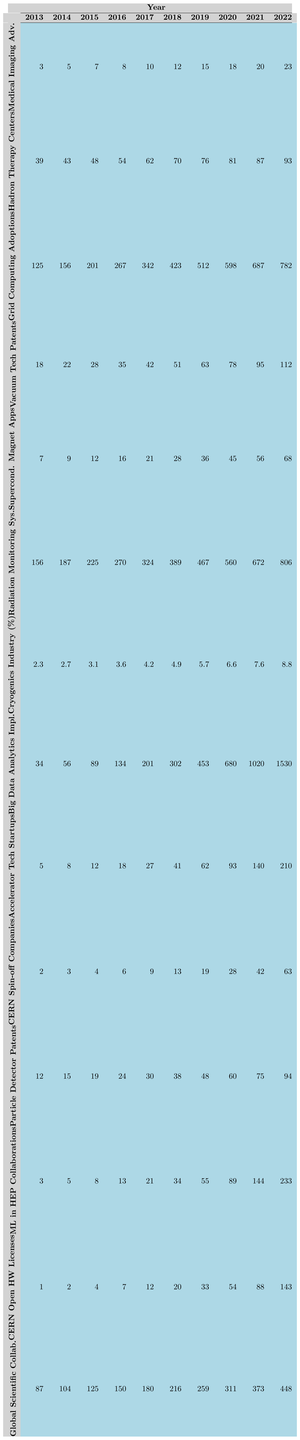What is the value for Radiation Monitoring Systems in 2021? In the table, under the column for Radiation Monitoring Systems, the value corresponding to the year 2021 is 672.
Answer: 672 How many Hadron Therapy Centers were there in 2019? Referring to the Hadron Therapy Centers row, for the year 2019 the value is 76.
Answer: 76 What was the increase in Vacuum Technology Patents from 2013 to 2022? The value in 2013 was 18 and in 2022 it was 112. The increase is 112 - 18 = 94.
Answer: 94 What is the average number of CERN Spin-off Companies over the decade? To find the average, sum the values from 2013 to 2022: (2 + 3 + 4 + 6 + 9 + 13 + 19 + 28 + 42 + 63 = 189). Then divide by the number of years (10): 189/10 = 18.9.
Answer: 18.9 How many more Accelerator Technology Startups were there in 2022 compared to 2015? In 2022 the value is 210 and in 2015 it was 12. The difference is 210 - 12 = 198.
Answer: 198 Was there an increase in Cryogenics Industry Growth from 2013 to 2022? Yes, the growth percentage increased from 2.3 in 2013 to 8.8 in 2022. This confirms an increase.
Answer: Yes What is the total number of Big Data Analytics Implementations from 2013 to 2022? Summing the values from 2013 to 2022 gives: 34 + 56 + 89 + 134 + 201 + 302 + 453 + 680 + 1020 + 1530 = 3069.
Answer: 3069 In which year did the Global Scientific Collaborations surpass 300? Checking the values for Global Scientific Collaborations, the year 2020 shows 311, which is the first instance of surpassing 300.
Answer: 2020 What percentage growth did Cryogenics experience from 2013 to 2022? The values are 2.3 in 2013 and 8.8 in 2022. The change is 8.8 - 2.3 = 6.5. The percentage increase is (6.5/2.3) * 100 ≈ 282.61%.
Answer: 282.61% How many years did it take for Machine Learning in HEP Collaborations to increase from 3 to over 200? The increase from 3 to 233 occurs between 2013 and 2022, which is 9 years.
Answer: 9 years 